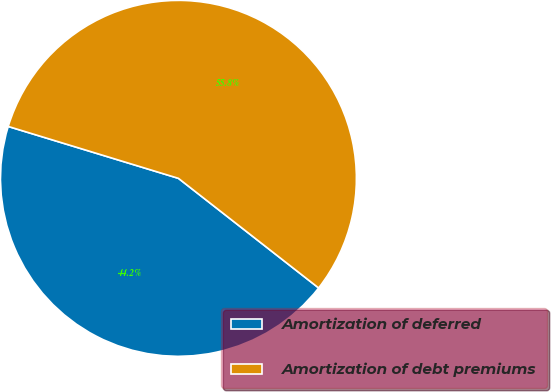Convert chart. <chart><loc_0><loc_0><loc_500><loc_500><pie_chart><fcel>Amortization of deferred<fcel>Amortization of debt premiums<nl><fcel>44.15%<fcel>55.85%<nl></chart> 